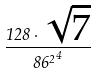<formula> <loc_0><loc_0><loc_500><loc_500>\frac { 1 2 8 \cdot \sqrt { 7 } } { { 8 6 ^ { 2 } } ^ { 4 } }</formula> 